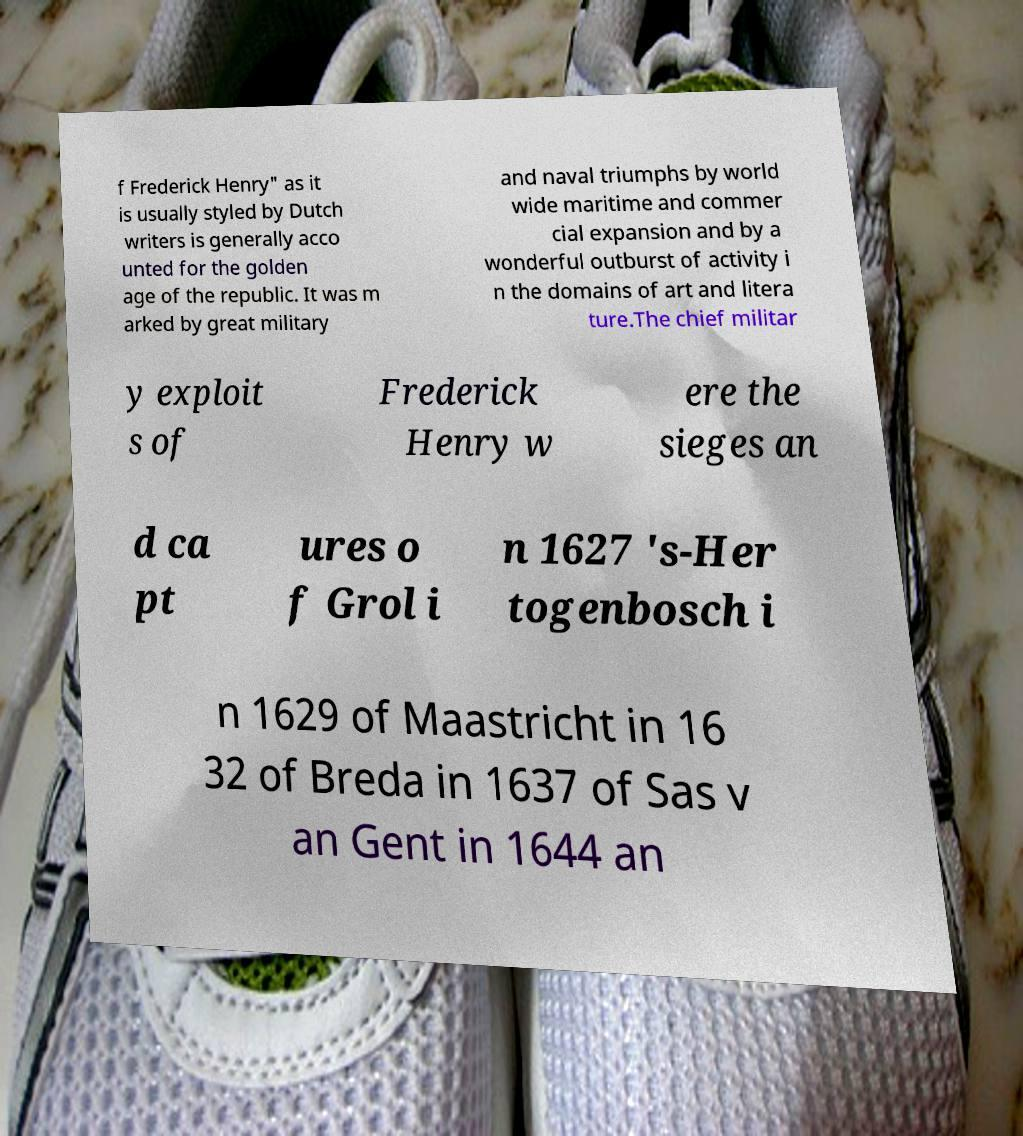Please identify and transcribe the text found in this image. f Frederick Henry" as it is usually styled by Dutch writers is generally acco unted for the golden age of the republic. It was m arked by great military and naval triumphs by world wide maritime and commer cial expansion and by a wonderful outburst of activity i n the domains of art and litera ture.The chief militar y exploit s of Frederick Henry w ere the sieges an d ca pt ures o f Grol i n 1627 's-Her togenbosch i n 1629 of Maastricht in 16 32 of Breda in 1637 of Sas v an Gent in 1644 an 